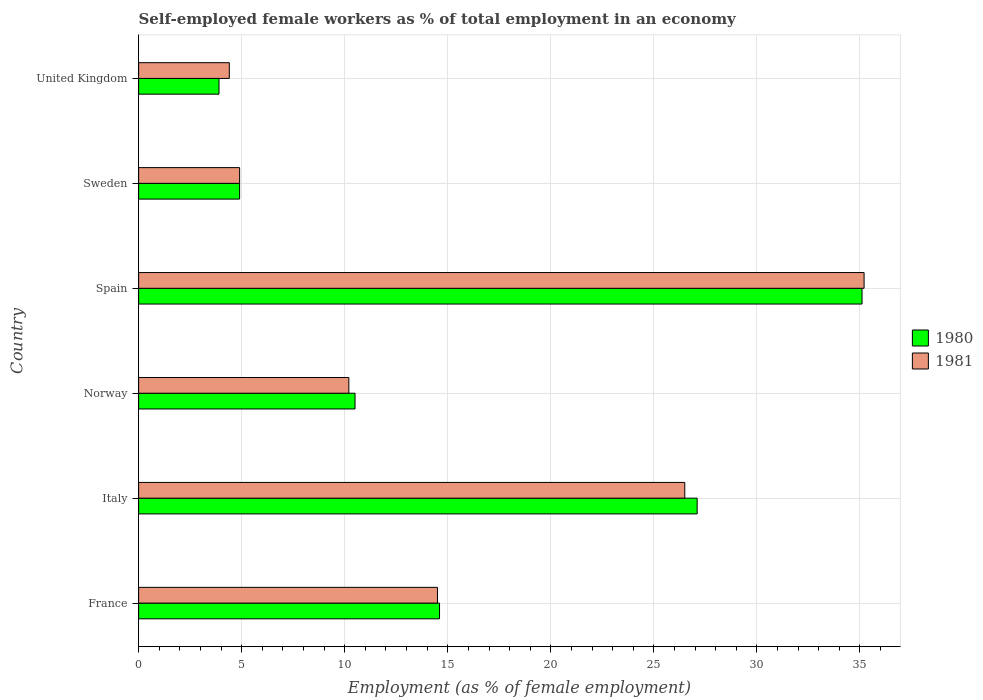How many groups of bars are there?
Keep it short and to the point. 6. How many bars are there on the 2nd tick from the top?
Make the answer very short. 2. How many bars are there on the 1st tick from the bottom?
Provide a succinct answer. 2. What is the label of the 5th group of bars from the top?
Keep it short and to the point. Italy. What is the percentage of self-employed female workers in 1980 in Spain?
Give a very brief answer. 35.1. Across all countries, what is the maximum percentage of self-employed female workers in 1981?
Give a very brief answer. 35.2. Across all countries, what is the minimum percentage of self-employed female workers in 1981?
Make the answer very short. 4.4. In which country was the percentage of self-employed female workers in 1981 maximum?
Keep it short and to the point. Spain. What is the total percentage of self-employed female workers in 1980 in the graph?
Offer a very short reply. 96.1. What is the difference between the percentage of self-employed female workers in 1980 in France and that in Spain?
Keep it short and to the point. -20.5. What is the difference between the percentage of self-employed female workers in 1980 in United Kingdom and the percentage of self-employed female workers in 1981 in Sweden?
Offer a very short reply. -1. What is the average percentage of self-employed female workers in 1981 per country?
Provide a succinct answer. 15.95. What is the difference between the percentage of self-employed female workers in 1981 and percentage of self-employed female workers in 1980 in United Kingdom?
Provide a succinct answer. 0.5. What is the ratio of the percentage of self-employed female workers in 1981 in Norway to that in Spain?
Provide a short and direct response. 0.29. Is the percentage of self-employed female workers in 1981 in France less than that in United Kingdom?
Make the answer very short. No. What is the difference between the highest and the second highest percentage of self-employed female workers in 1980?
Make the answer very short. 8. What is the difference between the highest and the lowest percentage of self-employed female workers in 1980?
Offer a terse response. 31.2. Is the sum of the percentage of self-employed female workers in 1981 in France and Spain greater than the maximum percentage of self-employed female workers in 1980 across all countries?
Your answer should be very brief. Yes. What does the 2nd bar from the top in Sweden represents?
Offer a terse response. 1980. What is the difference between two consecutive major ticks on the X-axis?
Keep it short and to the point. 5. Are the values on the major ticks of X-axis written in scientific E-notation?
Keep it short and to the point. No. Does the graph contain grids?
Your answer should be very brief. Yes. Where does the legend appear in the graph?
Make the answer very short. Center right. What is the title of the graph?
Make the answer very short. Self-employed female workers as % of total employment in an economy. Does "2004" appear as one of the legend labels in the graph?
Offer a terse response. No. What is the label or title of the X-axis?
Your answer should be very brief. Employment (as % of female employment). What is the Employment (as % of female employment) of 1980 in France?
Your answer should be very brief. 14.6. What is the Employment (as % of female employment) in 1981 in France?
Your answer should be compact. 14.5. What is the Employment (as % of female employment) in 1980 in Italy?
Provide a succinct answer. 27.1. What is the Employment (as % of female employment) of 1981 in Italy?
Offer a terse response. 26.5. What is the Employment (as % of female employment) of 1980 in Norway?
Give a very brief answer. 10.5. What is the Employment (as % of female employment) of 1981 in Norway?
Your response must be concise. 10.2. What is the Employment (as % of female employment) in 1980 in Spain?
Your answer should be very brief. 35.1. What is the Employment (as % of female employment) in 1981 in Spain?
Offer a very short reply. 35.2. What is the Employment (as % of female employment) of 1980 in Sweden?
Offer a terse response. 4.9. What is the Employment (as % of female employment) of 1981 in Sweden?
Keep it short and to the point. 4.9. What is the Employment (as % of female employment) of 1980 in United Kingdom?
Your response must be concise. 3.9. What is the Employment (as % of female employment) of 1981 in United Kingdom?
Offer a terse response. 4.4. Across all countries, what is the maximum Employment (as % of female employment) in 1980?
Make the answer very short. 35.1. Across all countries, what is the maximum Employment (as % of female employment) of 1981?
Keep it short and to the point. 35.2. Across all countries, what is the minimum Employment (as % of female employment) in 1980?
Offer a very short reply. 3.9. Across all countries, what is the minimum Employment (as % of female employment) in 1981?
Provide a short and direct response. 4.4. What is the total Employment (as % of female employment) of 1980 in the graph?
Offer a terse response. 96.1. What is the total Employment (as % of female employment) of 1981 in the graph?
Your response must be concise. 95.7. What is the difference between the Employment (as % of female employment) in 1981 in France and that in Norway?
Offer a very short reply. 4.3. What is the difference between the Employment (as % of female employment) of 1980 in France and that in Spain?
Ensure brevity in your answer.  -20.5. What is the difference between the Employment (as % of female employment) of 1981 in France and that in Spain?
Make the answer very short. -20.7. What is the difference between the Employment (as % of female employment) of 1980 in France and that in Sweden?
Ensure brevity in your answer.  9.7. What is the difference between the Employment (as % of female employment) in 1981 in France and that in United Kingdom?
Your answer should be very brief. 10.1. What is the difference between the Employment (as % of female employment) of 1980 in Italy and that in Norway?
Your response must be concise. 16.6. What is the difference between the Employment (as % of female employment) in 1981 in Italy and that in Norway?
Make the answer very short. 16.3. What is the difference between the Employment (as % of female employment) in 1981 in Italy and that in Spain?
Offer a very short reply. -8.7. What is the difference between the Employment (as % of female employment) in 1981 in Italy and that in Sweden?
Give a very brief answer. 21.6. What is the difference between the Employment (as % of female employment) of 1980 in Italy and that in United Kingdom?
Offer a terse response. 23.2. What is the difference between the Employment (as % of female employment) in 1981 in Italy and that in United Kingdom?
Keep it short and to the point. 22.1. What is the difference between the Employment (as % of female employment) in 1980 in Norway and that in Spain?
Offer a very short reply. -24.6. What is the difference between the Employment (as % of female employment) in 1980 in Norway and that in Sweden?
Offer a terse response. 5.6. What is the difference between the Employment (as % of female employment) of 1981 in Norway and that in Sweden?
Make the answer very short. 5.3. What is the difference between the Employment (as % of female employment) in 1980 in Norway and that in United Kingdom?
Provide a succinct answer. 6.6. What is the difference between the Employment (as % of female employment) in 1981 in Norway and that in United Kingdom?
Make the answer very short. 5.8. What is the difference between the Employment (as % of female employment) of 1980 in Spain and that in Sweden?
Provide a short and direct response. 30.2. What is the difference between the Employment (as % of female employment) in 1981 in Spain and that in Sweden?
Offer a very short reply. 30.3. What is the difference between the Employment (as % of female employment) in 1980 in Spain and that in United Kingdom?
Keep it short and to the point. 31.2. What is the difference between the Employment (as % of female employment) of 1981 in Spain and that in United Kingdom?
Provide a succinct answer. 30.8. What is the difference between the Employment (as % of female employment) of 1980 in Sweden and that in United Kingdom?
Give a very brief answer. 1. What is the difference between the Employment (as % of female employment) in 1980 in France and the Employment (as % of female employment) in 1981 in Spain?
Provide a succinct answer. -20.6. What is the difference between the Employment (as % of female employment) in 1980 in France and the Employment (as % of female employment) in 1981 in United Kingdom?
Offer a terse response. 10.2. What is the difference between the Employment (as % of female employment) of 1980 in Italy and the Employment (as % of female employment) of 1981 in Norway?
Give a very brief answer. 16.9. What is the difference between the Employment (as % of female employment) in 1980 in Italy and the Employment (as % of female employment) in 1981 in Sweden?
Keep it short and to the point. 22.2. What is the difference between the Employment (as % of female employment) in 1980 in Italy and the Employment (as % of female employment) in 1981 in United Kingdom?
Ensure brevity in your answer.  22.7. What is the difference between the Employment (as % of female employment) in 1980 in Norway and the Employment (as % of female employment) in 1981 in Spain?
Provide a short and direct response. -24.7. What is the difference between the Employment (as % of female employment) in 1980 in Norway and the Employment (as % of female employment) in 1981 in Sweden?
Offer a terse response. 5.6. What is the difference between the Employment (as % of female employment) in 1980 in Spain and the Employment (as % of female employment) in 1981 in Sweden?
Provide a short and direct response. 30.2. What is the difference between the Employment (as % of female employment) of 1980 in Spain and the Employment (as % of female employment) of 1981 in United Kingdom?
Your answer should be compact. 30.7. What is the difference between the Employment (as % of female employment) in 1980 in Sweden and the Employment (as % of female employment) in 1981 in United Kingdom?
Offer a very short reply. 0.5. What is the average Employment (as % of female employment) of 1980 per country?
Offer a very short reply. 16.02. What is the average Employment (as % of female employment) of 1981 per country?
Make the answer very short. 15.95. What is the difference between the Employment (as % of female employment) of 1980 and Employment (as % of female employment) of 1981 in Italy?
Your answer should be compact. 0.6. What is the difference between the Employment (as % of female employment) of 1980 and Employment (as % of female employment) of 1981 in Norway?
Your response must be concise. 0.3. What is the difference between the Employment (as % of female employment) in 1980 and Employment (as % of female employment) in 1981 in Spain?
Your response must be concise. -0.1. What is the ratio of the Employment (as % of female employment) in 1980 in France to that in Italy?
Provide a short and direct response. 0.54. What is the ratio of the Employment (as % of female employment) in 1981 in France to that in Italy?
Your answer should be very brief. 0.55. What is the ratio of the Employment (as % of female employment) of 1980 in France to that in Norway?
Your answer should be very brief. 1.39. What is the ratio of the Employment (as % of female employment) in 1981 in France to that in Norway?
Keep it short and to the point. 1.42. What is the ratio of the Employment (as % of female employment) of 1980 in France to that in Spain?
Your answer should be compact. 0.42. What is the ratio of the Employment (as % of female employment) in 1981 in France to that in Spain?
Give a very brief answer. 0.41. What is the ratio of the Employment (as % of female employment) in 1980 in France to that in Sweden?
Your response must be concise. 2.98. What is the ratio of the Employment (as % of female employment) in 1981 in France to that in Sweden?
Provide a short and direct response. 2.96. What is the ratio of the Employment (as % of female employment) of 1980 in France to that in United Kingdom?
Offer a terse response. 3.74. What is the ratio of the Employment (as % of female employment) in 1981 in France to that in United Kingdom?
Provide a succinct answer. 3.3. What is the ratio of the Employment (as % of female employment) of 1980 in Italy to that in Norway?
Keep it short and to the point. 2.58. What is the ratio of the Employment (as % of female employment) in 1981 in Italy to that in Norway?
Keep it short and to the point. 2.6. What is the ratio of the Employment (as % of female employment) of 1980 in Italy to that in Spain?
Provide a succinct answer. 0.77. What is the ratio of the Employment (as % of female employment) in 1981 in Italy to that in Spain?
Your answer should be very brief. 0.75. What is the ratio of the Employment (as % of female employment) in 1980 in Italy to that in Sweden?
Offer a very short reply. 5.53. What is the ratio of the Employment (as % of female employment) in 1981 in Italy to that in Sweden?
Provide a short and direct response. 5.41. What is the ratio of the Employment (as % of female employment) of 1980 in Italy to that in United Kingdom?
Ensure brevity in your answer.  6.95. What is the ratio of the Employment (as % of female employment) in 1981 in Italy to that in United Kingdom?
Your response must be concise. 6.02. What is the ratio of the Employment (as % of female employment) of 1980 in Norway to that in Spain?
Your answer should be very brief. 0.3. What is the ratio of the Employment (as % of female employment) in 1981 in Norway to that in Spain?
Your response must be concise. 0.29. What is the ratio of the Employment (as % of female employment) in 1980 in Norway to that in Sweden?
Provide a succinct answer. 2.14. What is the ratio of the Employment (as % of female employment) of 1981 in Norway to that in Sweden?
Provide a short and direct response. 2.08. What is the ratio of the Employment (as % of female employment) of 1980 in Norway to that in United Kingdom?
Offer a very short reply. 2.69. What is the ratio of the Employment (as % of female employment) of 1981 in Norway to that in United Kingdom?
Provide a succinct answer. 2.32. What is the ratio of the Employment (as % of female employment) in 1980 in Spain to that in Sweden?
Offer a terse response. 7.16. What is the ratio of the Employment (as % of female employment) in 1981 in Spain to that in Sweden?
Offer a terse response. 7.18. What is the ratio of the Employment (as % of female employment) of 1981 in Spain to that in United Kingdom?
Your answer should be compact. 8. What is the ratio of the Employment (as % of female employment) in 1980 in Sweden to that in United Kingdom?
Keep it short and to the point. 1.26. What is the ratio of the Employment (as % of female employment) of 1981 in Sweden to that in United Kingdom?
Keep it short and to the point. 1.11. What is the difference between the highest and the second highest Employment (as % of female employment) of 1981?
Provide a short and direct response. 8.7. What is the difference between the highest and the lowest Employment (as % of female employment) in 1980?
Make the answer very short. 31.2. What is the difference between the highest and the lowest Employment (as % of female employment) of 1981?
Provide a short and direct response. 30.8. 